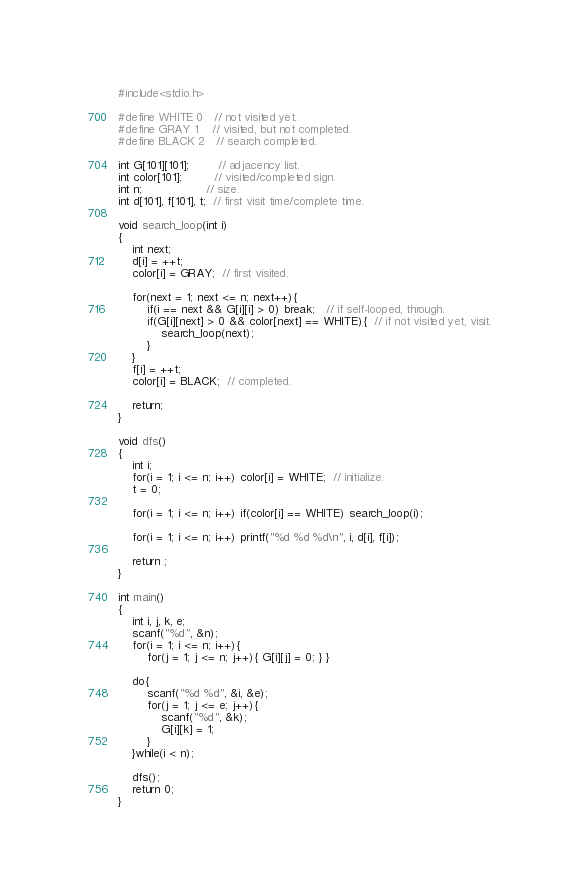<code> <loc_0><loc_0><loc_500><loc_500><_C++_>#include<stdio.h>

#define WHITE 0   // not visited yet.
#define GRAY 1    // visited, but not completed.
#define BLACK 2   // search completed.

int G[101][101];        // adjacency list.
int color[101];         // visited/completed sign.
int n;                  // size.
int d[101], f[101], t;  // first visit time/complete time.

void search_loop(int i) 
{
    int next;
    d[i] = ++t;
    color[i] = GRAY;  // first visited.

    for(next = 1; next <= n; next++){
        if(i == next && G[i][i] > 0) break;   // if self-looped, through.
        if(G[i][next] > 0 && color[next] == WHITE){  // if not visited yet, visit.
            search_loop(next);
        }
    }
    f[i] = ++t;
    color[i] = BLACK;  // completed. 

    return;
}

void dfs()
{
    int i;
    for(i = 1; i <= n; i++) color[i] = WHITE;  // initialize.
    t = 0;

    for(i = 1; i <= n; i++) if(color[i] == WHITE) search_loop(i);

    for(i = 1; i <= n; i++) printf("%d %d %d\n", i, d[i], f[i]);

    return ;
}

int main()
{
    int i, j, k, e;
    scanf("%d", &n);
    for(i = 1; i <= n; i++){
        for(j = 1; j <= n; j++){ G[i][j] = 0; } }

    do{
        scanf("%d %d", &i, &e);
        for(j = 1; j <= e; j++){
            scanf("%d", &k);
            G[i][k] = 1;
        }
    }while(i < n);

    dfs();
    return 0;
}</code> 